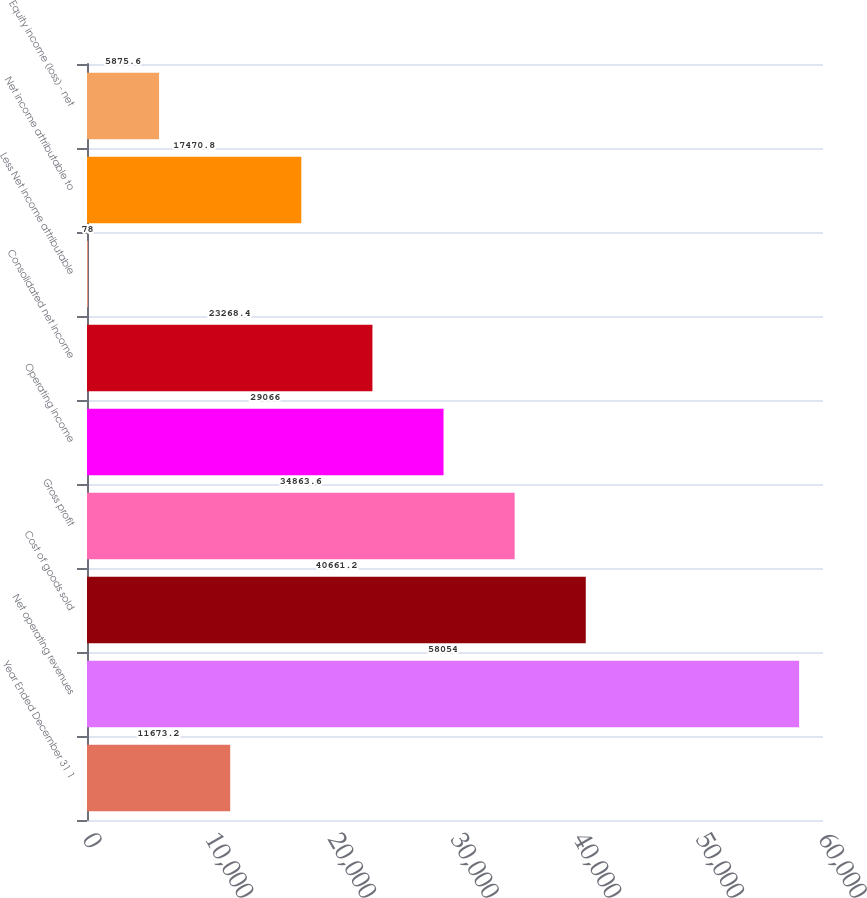Convert chart. <chart><loc_0><loc_0><loc_500><loc_500><bar_chart><fcel>Year Ended December 31 1<fcel>Net operating revenues<fcel>Cost of goods sold<fcel>Gross profit<fcel>Operating income<fcel>Consolidated net income<fcel>Less Net income attributable<fcel>Net income attributable to<fcel>Equity income (loss) - net<nl><fcel>11673.2<fcel>58054<fcel>40661.2<fcel>34863.6<fcel>29066<fcel>23268.4<fcel>78<fcel>17470.8<fcel>5875.6<nl></chart> 